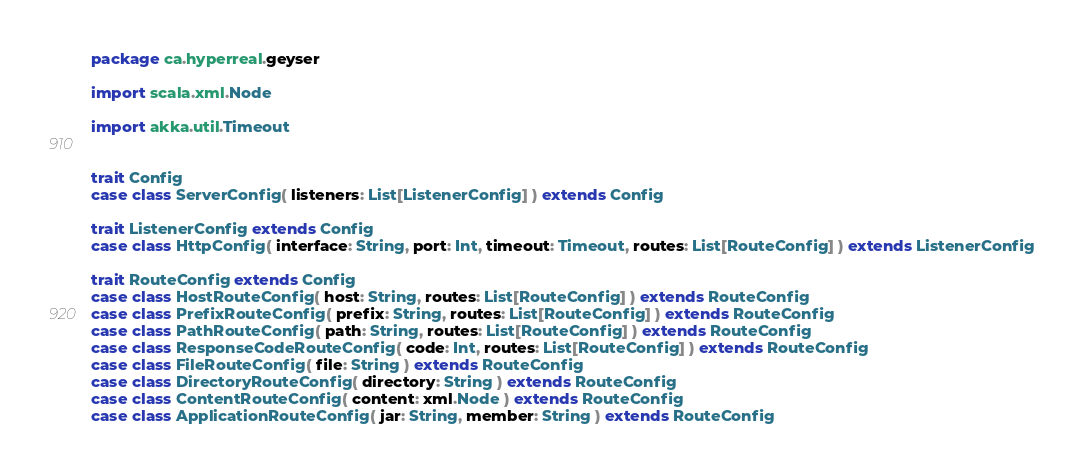<code> <loc_0><loc_0><loc_500><loc_500><_Scala_>package ca.hyperreal.geyser

import scala.xml.Node

import akka.util.Timeout


trait Config
case class ServerConfig( listeners: List[ListenerConfig] ) extends Config

trait ListenerConfig extends Config
case class HttpConfig( interface: String, port: Int, timeout: Timeout, routes: List[RouteConfig] ) extends ListenerConfig

trait RouteConfig extends Config
case class HostRouteConfig( host: String, routes: List[RouteConfig] ) extends RouteConfig
case class PrefixRouteConfig( prefix: String, routes: List[RouteConfig] ) extends RouteConfig
case class PathRouteConfig( path: String, routes: List[RouteConfig] ) extends RouteConfig
case class ResponseCodeRouteConfig( code: Int, routes: List[RouteConfig] ) extends RouteConfig
case class FileRouteConfig( file: String ) extends RouteConfig
case class DirectoryRouteConfig( directory: String ) extends RouteConfig
case class ContentRouteConfig( content: xml.Node ) extends RouteConfig
case class ApplicationRouteConfig( jar: String, member: String ) extends RouteConfig</code> 